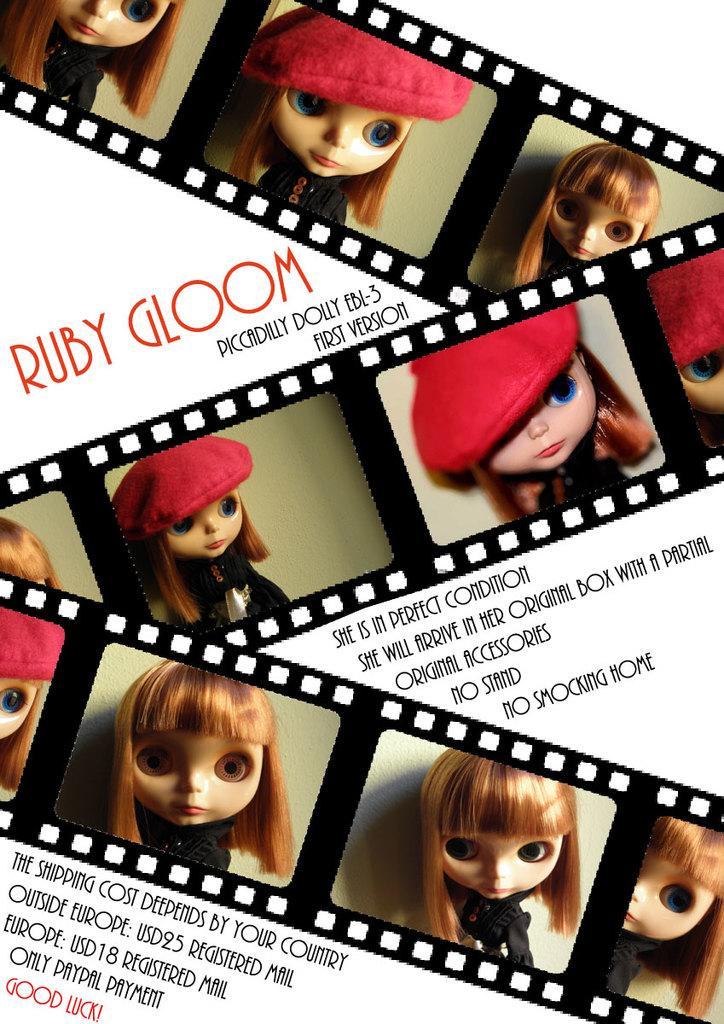What type of editing has been done to the image? The image is edited, but the specific type of editing is not mentioned. What can be seen on the reel in the image? There are pictures of toy girls on the reel. Are there any words or phrases written on the image? Yes, there are texts written on the image. How many snails can be seen crawling on the toy girls in the image? There are no snails present in the image; it features pictures of toy girls on a reel. What direction should you look in to find the cherries in the image? There are no cherries present in the image. 